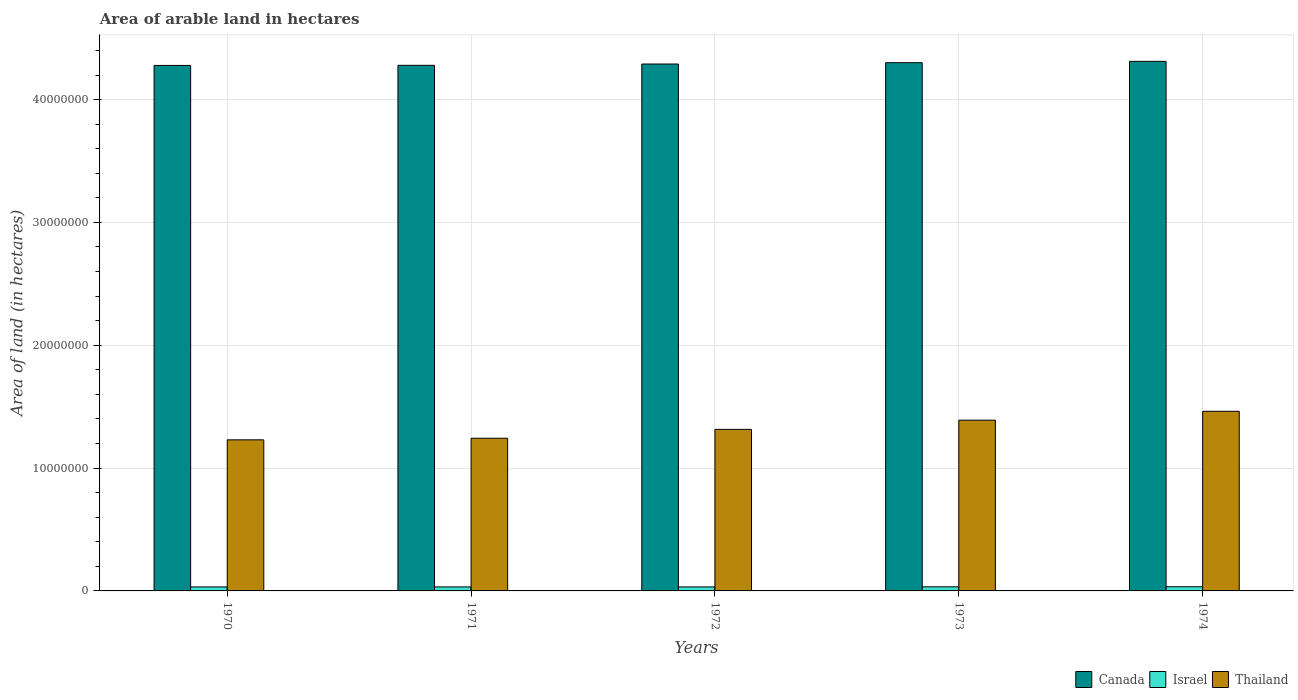How many different coloured bars are there?
Offer a terse response. 3. Are the number of bars per tick equal to the number of legend labels?
Make the answer very short. Yes. How many bars are there on the 1st tick from the left?
Keep it short and to the point. 3. How many bars are there on the 2nd tick from the right?
Your response must be concise. 3. What is the label of the 5th group of bars from the left?
Give a very brief answer. 1974. What is the total arable land in Thailand in 1971?
Ensure brevity in your answer.  1.24e+07. Across all years, what is the maximum total arable land in Israel?
Offer a terse response. 3.39e+05. Across all years, what is the minimum total arable land in Thailand?
Provide a short and direct response. 1.23e+07. In which year was the total arable land in Thailand maximum?
Provide a succinct answer. 1974. What is the total total arable land in Israel in the graph?
Offer a very short reply. 1.65e+06. What is the difference between the total arable land in Canada in 1971 and that in 1974?
Offer a terse response. -3.23e+05. What is the difference between the total arable land in Thailand in 1974 and the total arable land in Israel in 1970?
Give a very brief answer. 1.43e+07. What is the average total arable land in Thailand per year?
Offer a very short reply. 1.33e+07. In the year 1972, what is the difference between the total arable land in Canada and total arable land in Israel?
Provide a succinct answer. 4.26e+07. What is the ratio of the total arable land in Israel in 1970 to that in 1974?
Your response must be concise. 0.96. What is the difference between the highest and the second highest total arable land in Canada?
Make the answer very short. 1.08e+05. What is the difference between the highest and the lowest total arable land in Canada?
Provide a short and direct response. 3.32e+05. In how many years, is the total arable land in Israel greater than the average total arable land in Israel taken over all years?
Keep it short and to the point. 2. What does the 1st bar from the left in 1972 represents?
Provide a short and direct response. Canada. What does the 1st bar from the right in 1974 represents?
Ensure brevity in your answer.  Thailand. Is it the case that in every year, the sum of the total arable land in Israel and total arable land in Canada is greater than the total arable land in Thailand?
Your response must be concise. Yes. How many years are there in the graph?
Your answer should be very brief. 5. What is the difference between two consecutive major ticks on the Y-axis?
Your answer should be very brief. 1.00e+07. What is the title of the graph?
Give a very brief answer. Area of arable land in hectares. Does "Afghanistan" appear as one of the legend labels in the graph?
Your answer should be very brief. No. What is the label or title of the X-axis?
Offer a very short reply. Years. What is the label or title of the Y-axis?
Ensure brevity in your answer.  Area of land (in hectares). What is the Area of land (in hectares) of Canada in 1970?
Offer a very short reply. 4.28e+07. What is the Area of land (in hectares) of Israel in 1970?
Give a very brief answer. 3.25e+05. What is the Area of land (in hectares) of Thailand in 1970?
Provide a short and direct response. 1.23e+07. What is the Area of land (in hectares) of Canada in 1971?
Your answer should be compact. 4.28e+07. What is the Area of land (in hectares) of Israel in 1971?
Ensure brevity in your answer.  3.26e+05. What is the Area of land (in hectares) in Thailand in 1971?
Provide a short and direct response. 1.24e+07. What is the Area of land (in hectares) in Canada in 1972?
Your answer should be very brief. 4.29e+07. What is the Area of land (in hectares) of Israel in 1972?
Your answer should be compact. 3.25e+05. What is the Area of land (in hectares) in Thailand in 1972?
Provide a short and direct response. 1.32e+07. What is the Area of land (in hectares) in Canada in 1973?
Provide a short and direct response. 4.30e+07. What is the Area of land (in hectares) in Israel in 1973?
Give a very brief answer. 3.34e+05. What is the Area of land (in hectares) of Thailand in 1973?
Keep it short and to the point. 1.39e+07. What is the Area of land (in hectares) in Canada in 1974?
Your answer should be very brief. 4.31e+07. What is the Area of land (in hectares) of Israel in 1974?
Your answer should be very brief. 3.39e+05. What is the Area of land (in hectares) in Thailand in 1974?
Offer a terse response. 1.46e+07. Across all years, what is the maximum Area of land (in hectares) of Canada?
Keep it short and to the point. 4.31e+07. Across all years, what is the maximum Area of land (in hectares) of Israel?
Make the answer very short. 3.39e+05. Across all years, what is the maximum Area of land (in hectares) of Thailand?
Keep it short and to the point. 1.46e+07. Across all years, what is the minimum Area of land (in hectares) in Canada?
Provide a succinct answer. 4.28e+07. Across all years, what is the minimum Area of land (in hectares) of Israel?
Make the answer very short. 3.25e+05. Across all years, what is the minimum Area of land (in hectares) in Thailand?
Provide a succinct answer. 1.23e+07. What is the total Area of land (in hectares) in Canada in the graph?
Keep it short and to the point. 2.15e+08. What is the total Area of land (in hectares) of Israel in the graph?
Your answer should be very brief. 1.65e+06. What is the total Area of land (in hectares) in Thailand in the graph?
Ensure brevity in your answer.  6.64e+07. What is the difference between the Area of land (in hectares) of Canada in 1970 and that in 1971?
Keep it short and to the point. -9000. What is the difference between the Area of land (in hectares) in Israel in 1970 and that in 1971?
Ensure brevity in your answer.  -1000. What is the difference between the Area of land (in hectares) in Thailand in 1970 and that in 1971?
Your response must be concise. -1.31e+05. What is the difference between the Area of land (in hectares) of Canada in 1970 and that in 1972?
Offer a very short reply. -1.16e+05. What is the difference between the Area of land (in hectares) in Thailand in 1970 and that in 1972?
Provide a succinct answer. -8.50e+05. What is the difference between the Area of land (in hectares) in Canada in 1970 and that in 1973?
Ensure brevity in your answer.  -2.24e+05. What is the difference between the Area of land (in hectares) of Israel in 1970 and that in 1973?
Offer a terse response. -9000. What is the difference between the Area of land (in hectares) of Thailand in 1970 and that in 1973?
Give a very brief answer. -1.60e+06. What is the difference between the Area of land (in hectares) in Canada in 1970 and that in 1974?
Provide a short and direct response. -3.32e+05. What is the difference between the Area of land (in hectares) in Israel in 1970 and that in 1974?
Offer a very short reply. -1.40e+04. What is the difference between the Area of land (in hectares) of Thailand in 1970 and that in 1974?
Your response must be concise. -2.32e+06. What is the difference between the Area of land (in hectares) in Canada in 1971 and that in 1972?
Offer a very short reply. -1.07e+05. What is the difference between the Area of land (in hectares) of Thailand in 1971 and that in 1972?
Make the answer very short. -7.19e+05. What is the difference between the Area of land (in hectares) in Canada in 1971 and that in 1973?
Offer a terse response. -2.15e+05. What is the difference between the Area of land (in hectares) of Israel in 1971 and that in 1973?
Your answer should be compact. -8000. What is the difference between the Area of land (in hectares) of Thailand in 1971 and that in 1973?
Provide a short and direct response. -1.47e+06. What is the difference between the Area of land (in hectares) in Canada in 1971 and that in 1974?
Offer a very short reply. -3.23e+05. What is the difference between the Area of land (in hectares) of Israel in 1971 and that in 1974?
Ensure brevity in your answer.  -1.30e+04. What is the difference between the Area of land (in hectares) of Thailand in 1971 and that in 1974?
Ensure brevity in your answer.  -2.19e+06. What is the difference between the Area of land (in hectares) of Canada in 1972 and that in 1973?
Offer a very short reply. -1.08e+05. What is the difference between the Area of land (in hectares) of Israel in 1972 and that in 1973?
Keep it short and to the point. -9000. What is the difference between the Area of land (in hectares) of Thailand in 1972 and that in 1973?
Offer a terse response. -7.50e+05. What is the difference between the Area of land (in hectares) in Canada in 1972 and that in 1974?
Your response must be concise. -2.16e+05. What is the difference between the Area of land (in hectares) of Israel in 1972 and that in 1974?
Your response must be concise. -1.40e+04. What is the difference between the Area of land (in hectares) of Thailand in 1972 and that in 1974?
Provide a short and direct response. -1.47e+06. What is the difference between the Area of land (in hectares) of Canada in 1973 and that in 1974?
Keep it short and to the point. -1.08e+05. What is the difference between the Area of land (in hectares) in Israel in 1973 and that in 1974?
Your response must be concise. -5000. What is the difference between the Area of land (in hectares) of Thailand in 1973 and that in 1974?
Provide a succinct answer. -7.24e+05. What is the difference between the Area of land (in hectares) of Canada in 1970 and the Area of land (in hectares) of Israel in 1971?
Make the answer very short. 4.25e+07. What is the difference between the Area of land (in hectares) in Canada in 1970 and the Area of land (in hectares) in Thailand in 1971?
Provide a succinct answer. 3.03e+07. What is the difference between the Area of land (in hectares) in Israel in 1970 and the Area of land (in hectares) in Thailand in 1971?
Provide a short and direct response. -1.21e+07. What is the difference between the Area of land (in hectares) of Canada in 1970 and the Area of land (in hectares) of Israel in 1972?
Your answer should be compact. 4.25e+07. What is the difference between the Area of land (in hectares) of Canada in 1970 and the Area of land (in hectares) of Thailand in 1972?
Your answer should be compact. 2.96e+07. What is the difference between the Area of land (in hectares) of Israel in 1970 and the Area of land (in hectares) of Thailand in 1972?
Make the answer very short. -1.28e+07. What is the difference between the Area of land (in hectares) in Canada in 1970 and the Area of land (in hectares) in Israel in 1973?
Give a very brief answer. 4.24e+07. What is the difference between the Area of land (in hectares) of Canada in 1970 and the Area of land (in hectares) of Thailand in 1973?
Ensure brevity in your answer.  2.89e+07. What is the difference between the Area of land (in hectares) of Israel in 1970 and the Area of land (in hectares) of Thailand in 1973?
Make the answer very short. -1.36e+07. What is the difference between the Area of land (in hectares) in Canada in 1970 and the Area of land (in hectares) in Israel in 1974?
Provide a succinct answer. 4.24e+07. What is the difference between the Area of land (in hectares) of Canada in 1970 and the Area of land (in hectares) of Thailand in 1974?
Provide a succinct answer. 2.82e+07. What is the difference between the Area of land (in hectares) in Israel in 1970 and the Area of land (in hectares) in Thailand in 1974?
Your answer should be very brief. -1.43e+07. What is the difference between the Area of land (in hectares) of Canada in 1971 and the Area of land (in hectares) of Israel in 1972?
Ensure brevity in your answer.  4.25e+07. What is the difference between the Area of land (in hectares) of Canada in 1971 and the Area of land (in hectares) of Thailand in 1972?
Provide a succinct answer. 2.96e+07. What is the difference between the Area of land (in hectares) in Israel in 1971 and the Area of land (in hectares) in Thailand in 1972?
Your answer should be very brief. -1.28e+07. What is the difference between the Area of land (in hectares) of Canada in 1971 and the Area of land (in hectares) of Israel in 1973?
Your response must be concise. 4.25e+07. What is the difference between the Area of land (in hectares) in Canada in 1971 and the Area of land (in hectares) in Thailand in 1973?
Your answer should be compact. 2.89e+07. What is the difference between the Area of land (in hectares) in Israel in 1971 and the Area of land (in hectares) in Thailand in 1973?
Your response must be concise. -1.36e+07. What is the difference between the Area of land (in hectares) in Canada in 1971 and the Area of land (in hectares) in Israel in 1974?
Your answer should be compact. 4.24e+07. What is the difference between the Area of land (in hectares) of Canada in 1971 and the Area of land (in hectares) of Thailand in 1974?
Provide a short and direct response. 2.82e+07. What is the difference between the Area of land (in hectares) in Israel in 1971 and the Area of land (in hectares) in Thailand in 1974?
Ensure brevity in your answer.  -1.43e+07. What is the difference between the Area of land (in hectares) of Canada in 1972 and the Area of land (in hectares) of Israel in 1973?
Your answer should be compact. 4.26e+07. What is the difference between the Area of land (in hectares) in Canada in 1972 and the Area of land (in hectares) in Thailand in 1973?
Keep it short and to the point. 2.90e+07. What is the difference between the Area of land (in hectares) of Israel in 1972 and the Area of land (in hectares) of Thailand in 1973?
Offer a very short reply. -1.36e+07. What is the difference between the Area of land (in hectares) in Canada in 1972 and the Area of land (in hectares) in Israel in 1974?
Make the answer very short. 4.26e+07. What is the difference between the Area of land (in hectares) of Canada in 1972 and the Area of land (in hectares) of Thailand in 1974?
Make the answer very short. 2.83e+07. What is the difference between the Area of land (in hectares) in Israel in 1972 and the Area of land (in hectares) in Thailand in 1974?
Provide a succinct answer. -1.43e+07. What is the difference between the Area of land (in hectares) of Canada in 1973 and the Area of land (in hectares) of Israel in 1974?
Keep it short and to the point. 4.27e+07. What is the difference between the Area of land (in hectares) in Canada in 1973 and the Area of land (in hectares) in Thailand in 1974?
Ensure brevity in your answer.  2.84e+07. What is the difference between the Area of land (in hectares) in Israel in 1973 and the Area of land (in hectares) in Thailand in 1974?
Your answer should be compact. -1.43e+07. What is the average Area of land (in hectares) of Canada per year?
Your answer should be very brief. 4.29e+07. What is the average Area of land (in hectares) in Israel per year?
Your response must be concise. 3.30e+05. What is the average Area of land (in hectares) of Thailand per year?
Your response must be concise. 1.33e+07. In the year 1970, what is the difference between the Area of land (in hectares) of Canada and Area of land (in hectares) of Israel?
Offer a terse response. 4.25e+07. In the year 1970, what is the difference between the Area of land (in hectares) in Canada and Area of land (in hectares) in Thailand?
Offer a very short reply. 3.05e+07. In the year 1970, what is the difference between the Area of land (in hectares) of Israel and Area of land (in hectares) of Thailand?
Provide a succinct answer. -1.20e+07. In the year 1971, what is the difference between the Area of land (in hectares) in Canada and Area of land (in hectares) in Israel?
Offer a very short reply. 4.25e+07. In the year 1971, what is the difference between the Area of land (in hectares) of Canada and Area of land (in hectares) of Thailand?
Make the answer very short. 3.04e+07. In the year 1971, what is the difference between the Area of land (in hectares) of Israel and Area of land (in hectares) of Thailand?
Keep it short and to the point. -1.21e+07. In the year 1972, what is the difference between the Area of land (in hectares) of Canada and Area of land (in hectares) of Israel?
Your answer should be very brief. 4.26e+07. In the year 1972, what is the difference between the Area of land (in hectares) in Canada and Area of land (in hectares) in Thailand?
Offer a terse response. 2.97e+07. In the year 1972, what is the difference between the Area of land (in hectares) of Israel and Area of land (in hectares) of Thailand?
Your answer should be very brief. -1.28e+07. In the year 1973, what is the difference between the Area of land (in hectares) of Canada and Area of land (in hectares) of Israel?
Keep it short and to the point. 4.27e+07. In the year 1973, what is the difference between the Area of land (in hectares) in Canada and Area of land (in hectares) in Thailand?
Give a very brief answer. 2.91e+07. In the year 1973, what is the difference between the Area of land (in hectares) of Israel and Area of land (in hectares) of Thailand?
Give a very brief answer. -1.36e+07. In the year 1974, what is the difference between the Area of land (in hectares) in Canada and Area of land (in hectares) in Israel?
Ensure brevity in your answer.  4.28e+07. In the year 1974, what is the difference between the Area of land (in hectares) in Canada and Area of land (in hectares) in Thailand?
Make the answer very short. 2.85e+07. In the year 1974, what is the difference between the Area of land (in hectares) in Israel and Area of land (in hectares) in Thailand?
Offer a very short reply. -1.43e+07. What is the ratio of the Area of land (in hectares) in Canada in 1970 to that in 1971?
Your answer should be compact. 1. What is the ratio of the Area of land (in hectares) of Thailand in 1970 to that in 1972?
Provide a succinct answer. 0.94. What is the ratio of the Area of land (in hectares) of Canada in 1970 to that in 1973?
Your response must be concise. 0.99. What is the ratio of the Area of land (in hectares) in Israel in 1970 to that in 1973?
Provide a short and direct response. 0.97. What is the ratio of the Area of land (in hectares) in Thailand in 1970 to that in 1973?
Your answer should be compact. 0.88. What is the ratio of the Area of land (in hectares) in Israel in 1970 to that in 1974?
Your answer should be very brief. 0.96. What is the ratio of the Area of land (in hectares) of Thailand in 1970 to that in 1974?
Ensure brevity in your answer.  0.84. What is the ratio of the Area of land (in hectares) of Canada in 1971 to that in 1972?
Your answer should be very brief. 1. What is the ratio of the Area of land (in hectares) of Israel in 1971 to that in 1972?
Your answer should be compact. 1. What is the ratio of the Area of land (in hectares) in Thailand in 1971 to that in 1972?
Offer a very short reply. 0.95. What is the ratio of the Area of land (in hectares) in Israel in 1971 to that in 1973?
Your response must be concise. 0.98. What is the ratio of the Area of land (in hectares) in Thailand in 1971 to that in 1973?
Keep it short and to the point. 0.89. What is the ratio of the Area of land (in hectares) in Canada in 1971 to that in 1974?
Give a very brief answer. 0.99. What is the ratio of the Area of land (in hectares) in Israel in 1971 to that in 1974?
Keep it short and to the point. 0.96. What is the ratio of the Area of land (in hectares) in Thailand in 1971 to that in 1974?
Your answer should be very brief. 0.85. What is the ratio of the Area of land (in hectares) of Israel in 1972 to that in 1973?
Ensure brevity in your answer.  0.97. What is the ratio of the Area of land (in hectares) in Thailand in 1972 to that in 1973?
Make the answer very short. 0.95. What is the ratio of the Area of land (in hectares) in Canada in 1972 to that in 1974?
Your answer should be very brief. 0.99. What is the ratio of the Area of land (in hectares) in Israel in 1972 to that in 1974?
Keep it short and to the point. 0.96. What is the ratio of the Area of land (in hectares) of Thailand in 1972 to that in 1974?
Offer a very short reply. 0.9. What is the ratio of the Area of land (in hectares) in Thailand in 1973 to that in 1974?
Offer a very short reply. 0.95. What is the difference between the highest and the second highest Area of land (in hectares) in Canada?
Your answer should be very brief. 1.08e+05. What is the difference between the highest and the second highest Area of land (in hectares) in Israel?
Offer a very short reply. 5000. What is the difference between the highest and the second highest Area of land (in hectares) of Thailand?
Make the answer very short. 7.24e+05. What is the difference between the highest and the lowest Area of land (in hectares) of Canada?
Provide a short and direct response. 3.32e+05. What is the difference between the highest and the lowest Area of land (in hectares) of Israel?
Your response must be concise. 1.40e+04. What is the difference between the highest and the lowest Area of land (in hectares) of Thailand?
Offer a very short reply. 2.32e+06. 